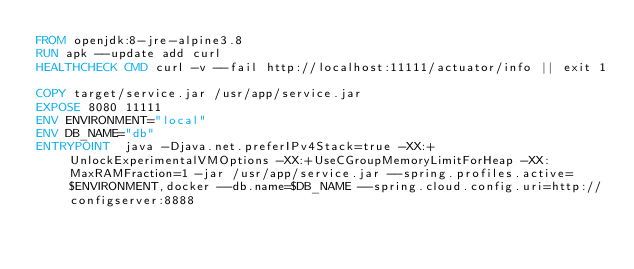<code> <loc_0><loc_0><loc_500><loc_500><_Dockerfile_>FROM openjdk:8-jre-alpine3.8
RUN apk --update add curl
HEALTHCHECK CMD curl -v --fail http://localhost:11111/actuator/info || exit 1

COPY target/service.jar /usr/app/service.jar
EXPOSE 8080 11111
ENV ENVIRONMENT="local"
ENV DB_NAME="db"
ENTRYPOINT  java -Djava.net.preferIPv4Stack=true -XX:+UnlockExperimentalVMOptions -XX:+UseCGroupMemoryLimitForHeap -XX:MaxRAMFraction=1 -jar /usr/app/service.jar --spring.profiles.active=$ENVIRONMENT,docker --db.name=$DB_NAME --spring.cloud.config.uri=http://configserver:8888</code> 